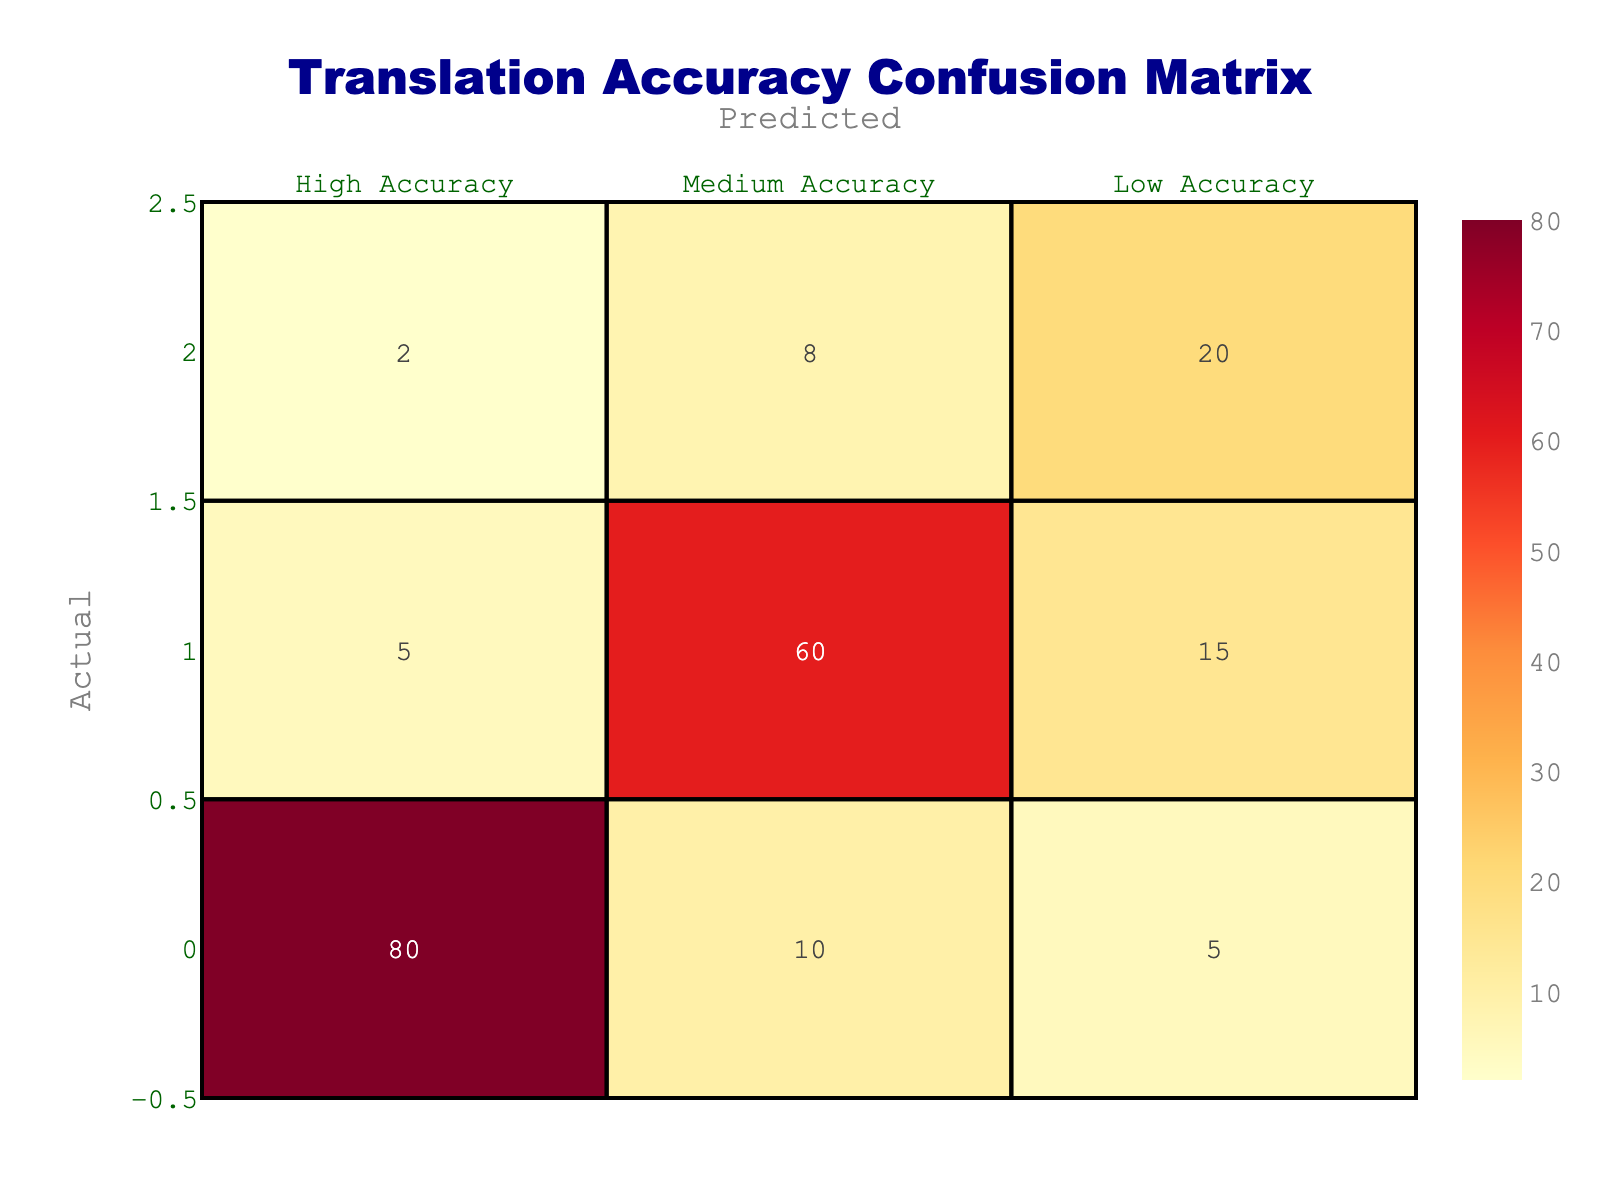What is the value for actual high accuracy predicted as medium accuracy? In the confusion matrix, the value corresponds to the intersection of actual high accuracy and predicted medium accuracy. Referring to the table, this value is 10.
Answer: 10 What is the total count of low accuracy predictions? To find this, we add the values in the "Low Accuracy" column: 5 (high accuracy) + 15 (medium accuracy) + 20 (low accuracy) = 40.
Answer: 40 Is the actual high accuracy count higher than the actual medium accuracy count? The actual high accuracy count is 80 (from the high accuracy row) and the actual medium accuracy count is 60 (from the medium accuracy row). Since 80 is greater than 60, the statement is true.
Answer: Yes What is the predicted accuracy rate for low accuracy when the actual accuracy is low? In the confusion matrix, the predicted accuracy for low accuracy where the actual accuracy is also low is found at the intersection of the actual low accuracy and predicted low accuracy, which gives us the value of 20.
Answer: 20 If we consider only the predictions where the actual accuracy is medium, what is the average predicted accuracy score? We only need the values from the medium accuracy row: 5 (high), 60 (medium), and 15 (low). Their sum is 80, and there are 3 data points, so the average is 80/3 = 26.67.
Answer: 26.67 What is the highest number of predicted accuracy for the actual low accuracy category? Referring to the actual low accuracy row in the confusion matrix, the values for predicted high accuracy, medium accuracy, and low accuracy are 2, 8, and 20, respectively. The highest of these values is 20.
Answer: 20 Are there more predicted medium accuracy translations than predicted low accuracy translations? We can look at the total counts for each category. For medium accuracy: 10 (high) + 60 (medium) + 15 (low) = 85. For low accuracy: 2 (high) + 8 (medium) + 20 (low) = 30. Since 85 is greater than 30, the statement is true.
Answer: Yes What is the percentage of high accuracy predictions in the total? The total predictions can be calculated by summing all values in the confusion matrix: 80 + 10 + 5 + 5 + 60 + 15 + 2 + 8 + 20 = 205. The number of high accuracy predictions is 80 + 10 + 5 = 95. Thus, the percentage is (95/205) * 100, which is approximately 46.34%.
Answer: 46.34% What is the difference between actual high accuracy and actual low accuracy counts? The actual high accuracy count is 80, and the actual low accuracy count is 20. By taking the difference, we have 80 - 20 = 60.
Answer: 60 